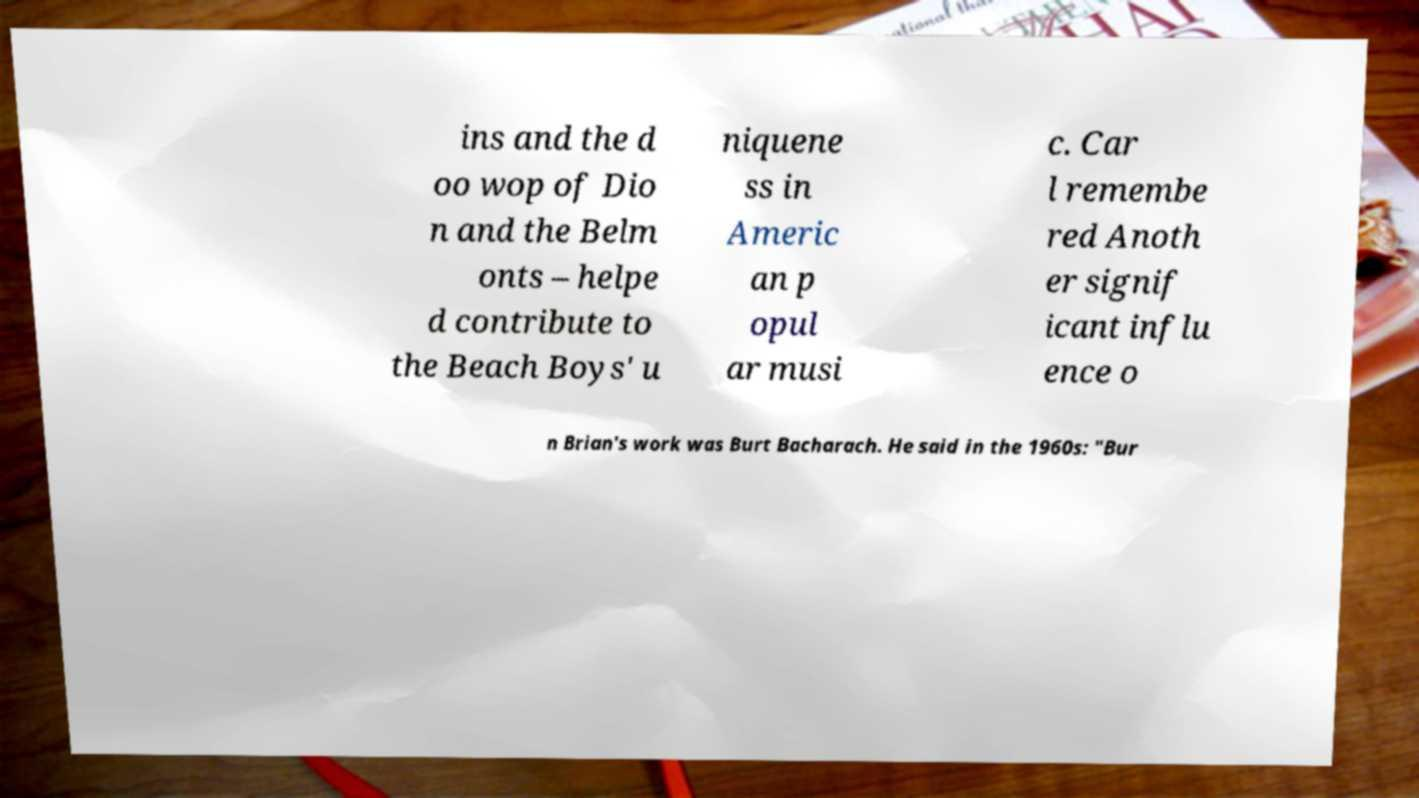Please read and relay the text visible in this image. What does it say? ins and the d oo wop of Dio n and the Belm onts – helpe d contribute to the Beach Boys' u niquene ss in Americ an p opul ar musi c. Car l remembe red Anoth er signif icant influ ence o n Brian's work was Burt Bacharach. He said in the 1960s: "Bur 